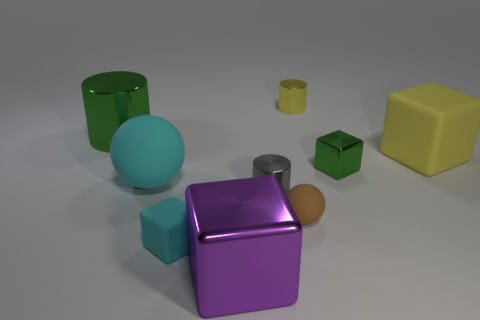What number of large shiny objects are the same color as the large ball?
Give a very brief answer. 0. There is a cyan matte object that is the same size as the green metallic cylinder; what is its shape?
Ensure brevity in your answer.  Sphere. Are there any gray metallic objects in front of the tiny brown rubber sphere?
Provide a succinct answer. No. Do the green metal block and the brown matte thing have the same size?
Keep it short and to the point. Yes. There is a cyan thing that is behind the tiny cyan matte block; what shape is it?
Provide a succinct answer. Sphere. Is there a yellow metal thing of the same size as the gray shiny cylinder?
Provide a succinct answer. Yes. There is a sphere that is the same size as the green cylinder; what material is it?
Ensure brevity in your answer.  Rubber. There is a ball in front of the big cyan matte thing; how big is it?
Your answer should be very brief. Small. What size is the cyan matte block?
Offer a terse response. Small. There is a green cylinder; does it have the same size as the green metal object right of the small gray metal cylinder?
Provide a short and direct response. No. 